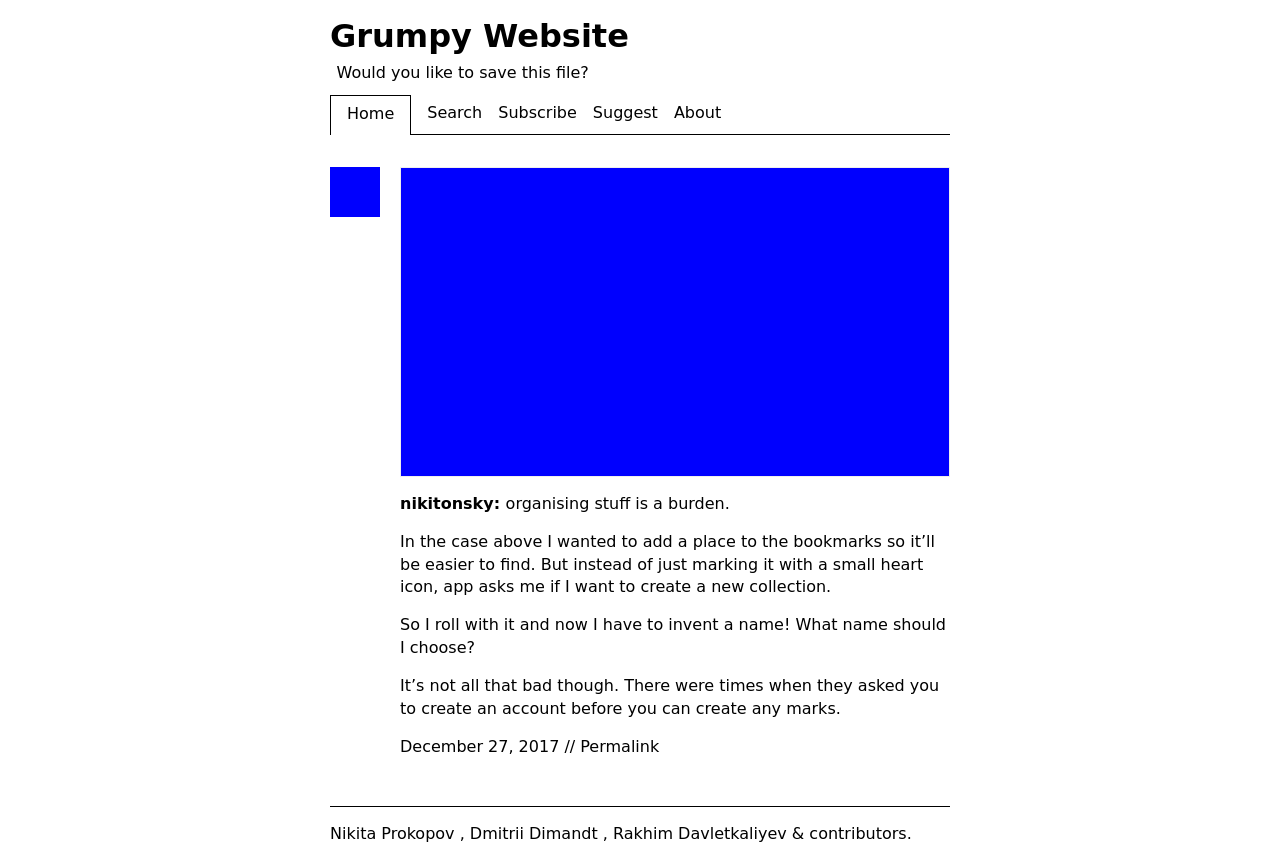Can you explain the purpose of the rotating icon in the website's subtitle section? The rotating icon in the website's subtitle section likely serves as a visual cue for interactivity, such as suggesting that clicking it could rotate the view of the page or trigger an animation. It also adds a playful element to the design, breaking the monotony of text and potentially engaging visitors to explore more based on curiosity.  What kind of functionality would you expect from the buttons in the website's menu? The buttons in the website's menu, like 'Home', 'Search', 'Subscribe', etc., are expected to lead users to different sections of the site. For instance, 'Search' would allow users to find specific content, 'Subscribe' might enable them to receive updates or newsletters, and 'About' would provide background information about the site or its creators. 